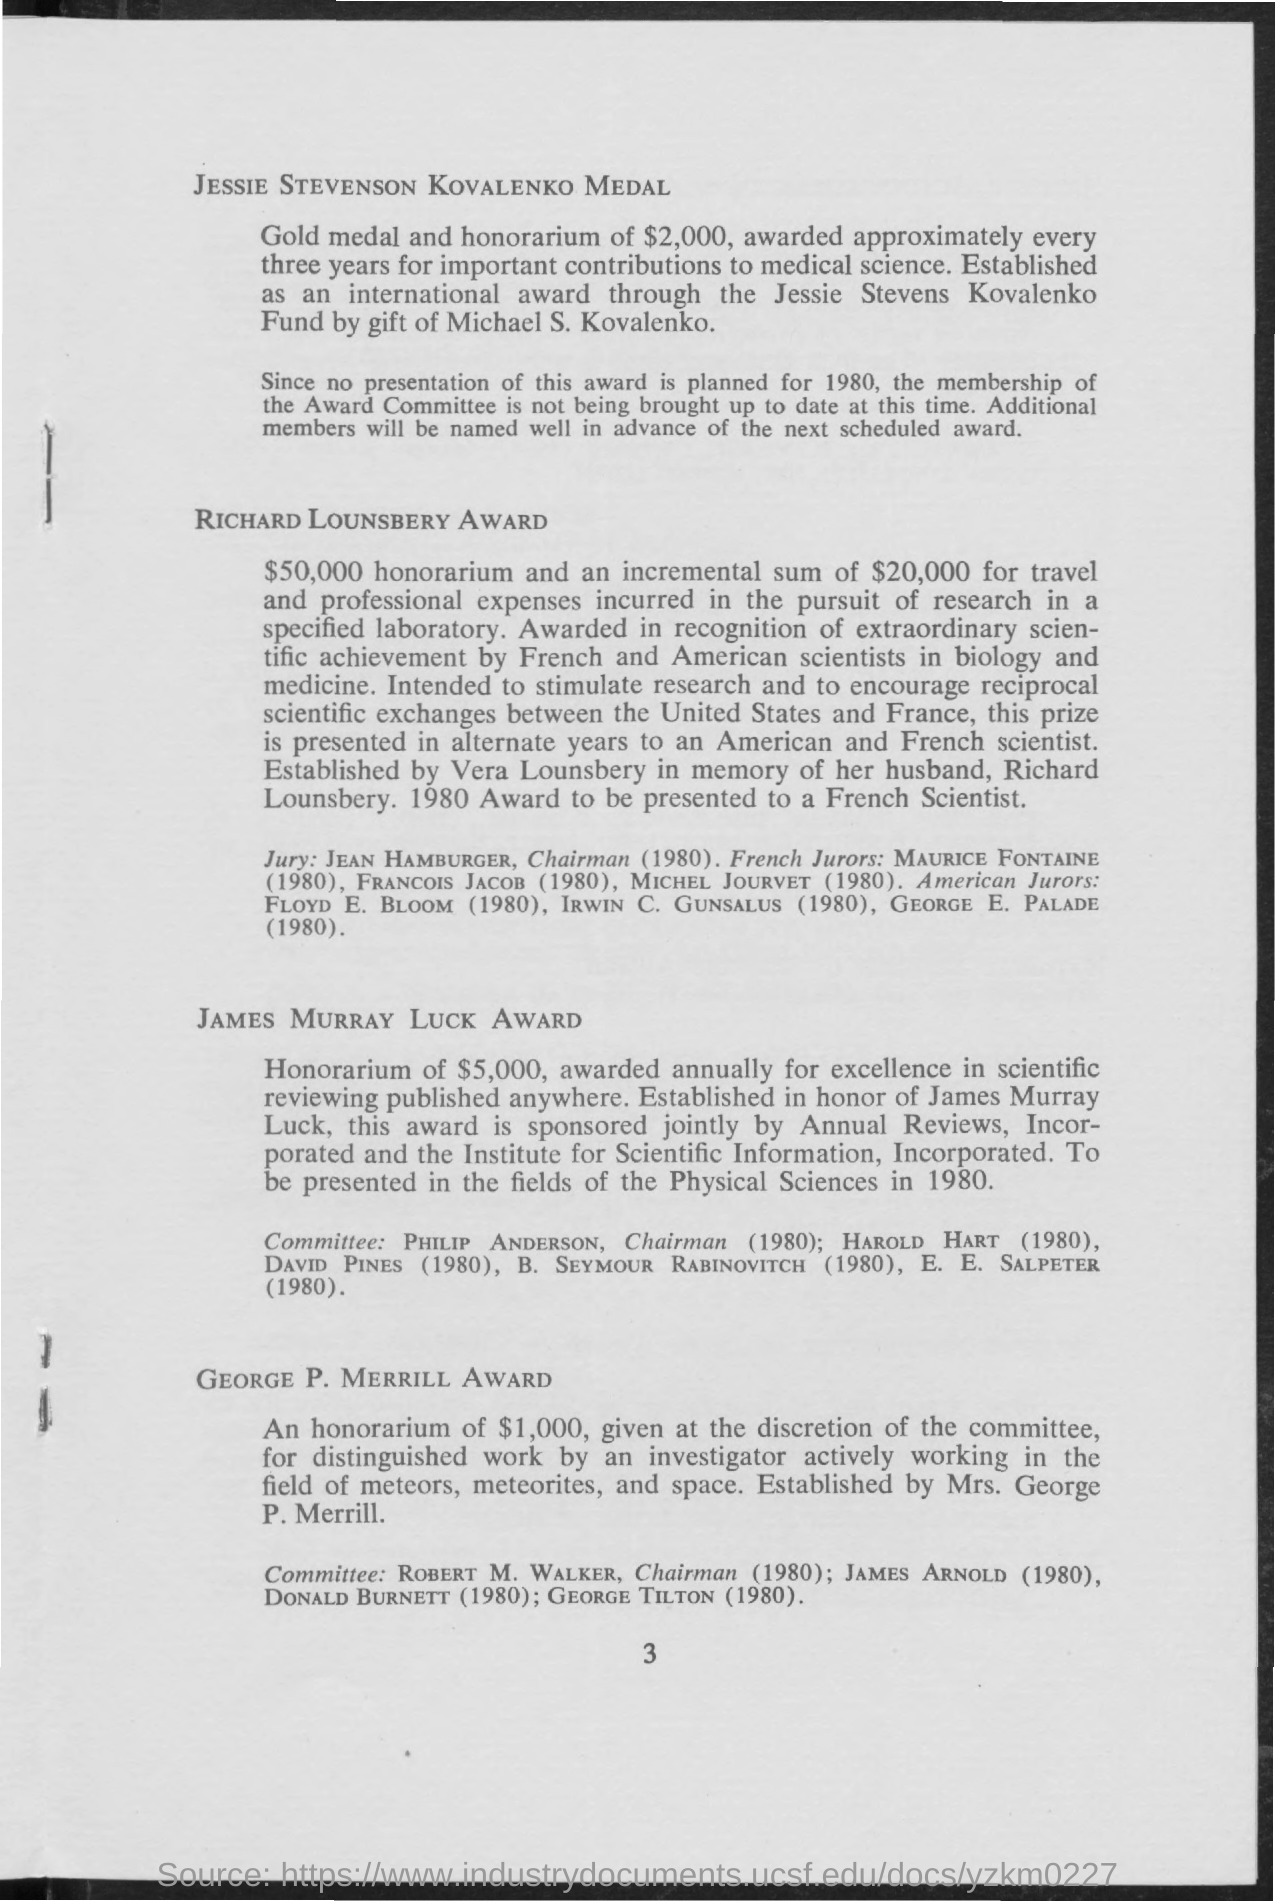What is the name of the medal in which gold medal and honorarium of $ 2,000 awarded approximately every three years for important contributions to medical science ?
Your response must be concise. Jessie Stevenson Kovalenko Medal. What is the name of the award in which $ 50,000 honorarium and an incremental sum of $ 20,000 for travel  and professional expenses incurred in a specifies laboratory ?
Your answer should be compact. Richard lounsbery award. In 1980 richard lounsbery award was given to which scientist ?
Offer a terse response. French scientist. What is the name of the award in which honorarium of $ 5,000, awarded annually for excellence in scientific reviewing published anywhere ?
Give a very brief answer. James murray luck award. In 1980 lames murray luck award was given in the fields of ?
Make the answer very short. Physical sciences. What is the amount given in george p. merrill award ?
Your answer should be compact. $1,000. George P.Merrill Award was given to the workers for working in the fields of ?
Keep it short and to the point. Meteors, meteorites, and space. 